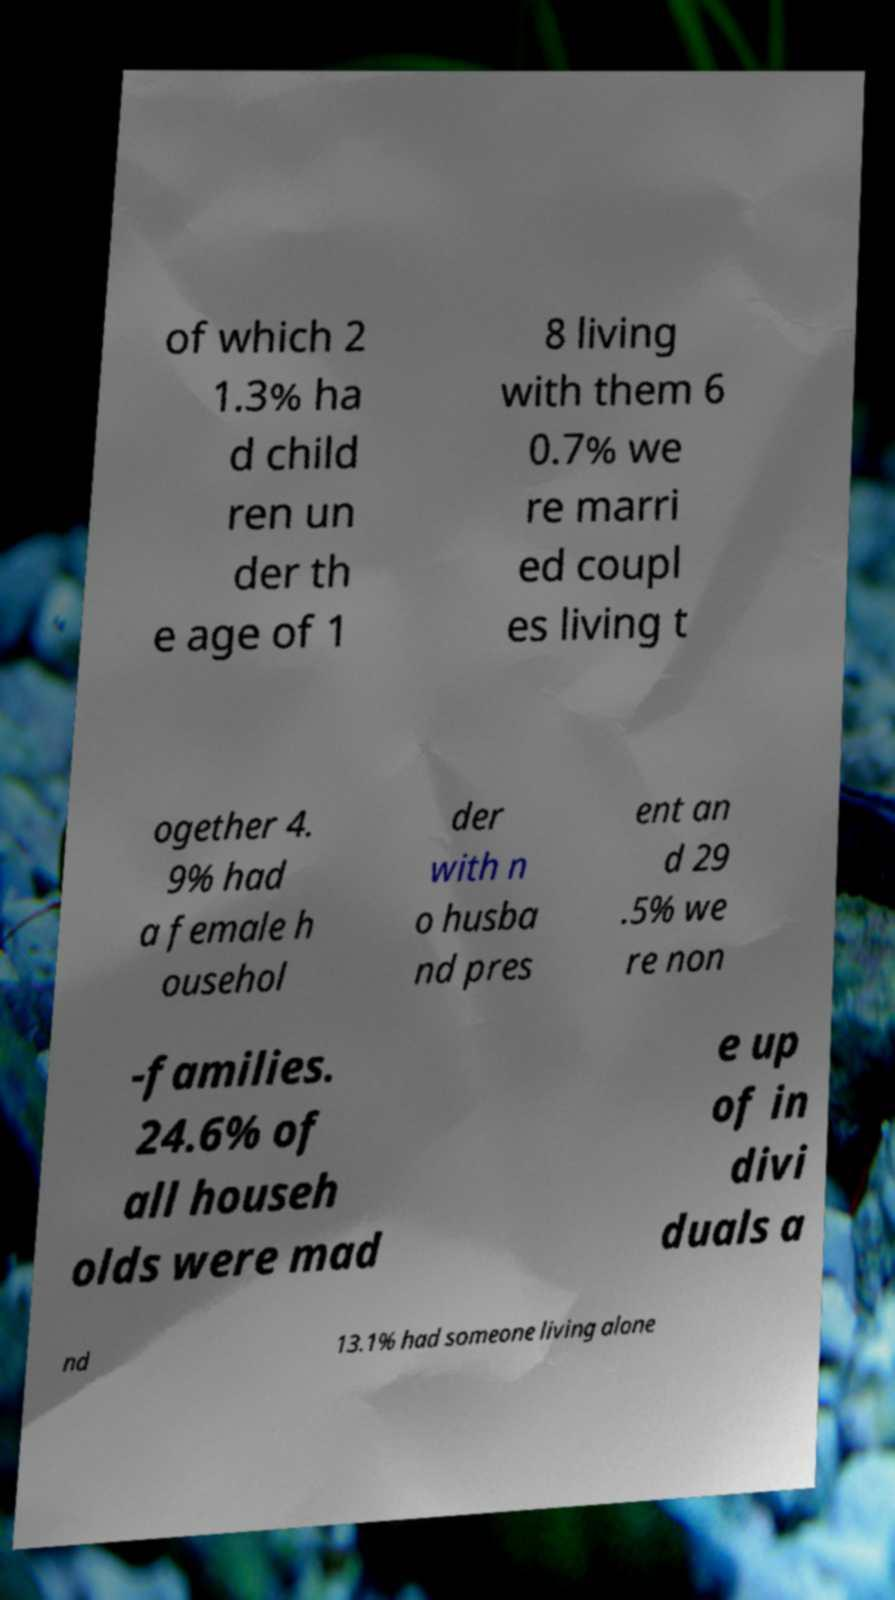Could you extract and type out the text from this image? of which 2 1.3% ha d child ren un der th e age of 1 8 living with them 6 0.7% we re marri ed coupl es living t ogether 4. 9% had a female h ousehol der with n o husba nd pres ent an d 29 .5% we re non -families. 24.6% of all househ olds were mad e up of in divi duals a nd 13.1% had someone living alone 